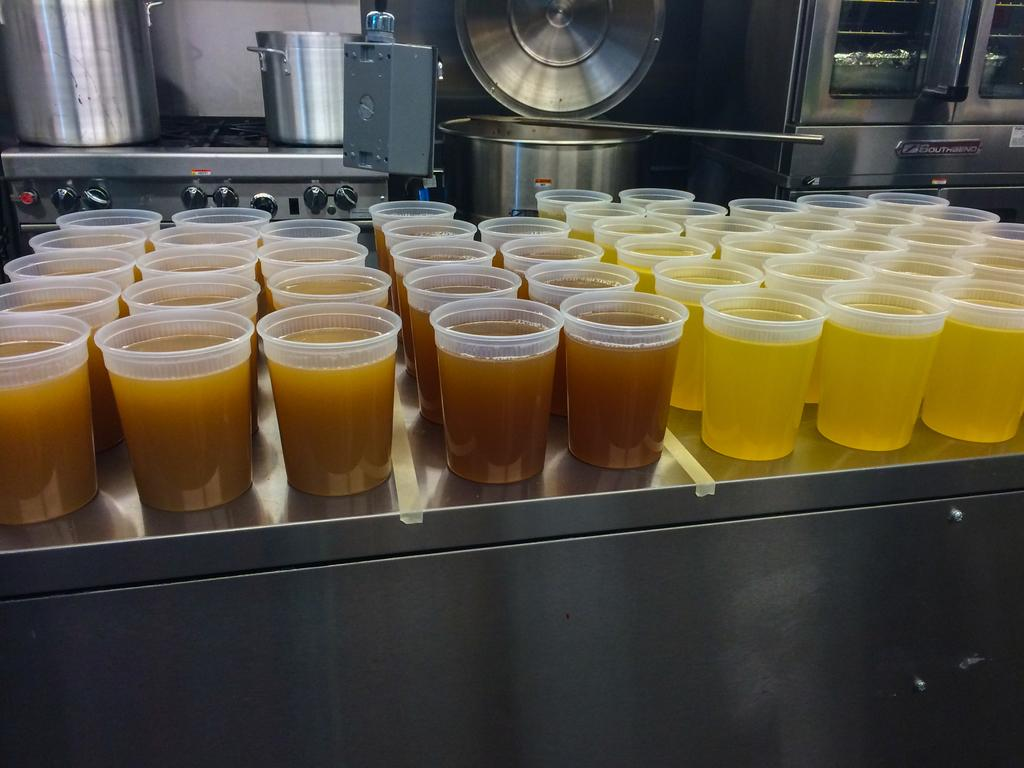What is the main piece of furniture in the image? There is a table in the image. What is on the table? There are glasses with liquid on the table. What can be seen in the background of the image? There are machines, jars, and a refrigerator in the background of the image. What type of plantation can be seen in the image? There is no plantation present in the image. What scent is emanating from the glasses with liquid? The image does not provide information about the scent of the liquid in the glasses. 